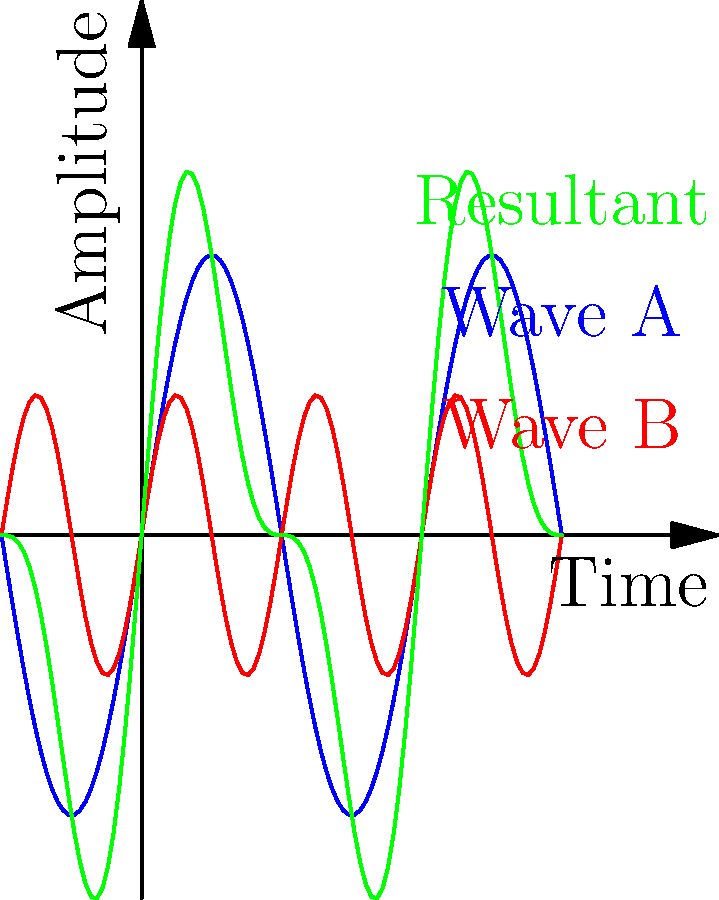In the studio, you're mixing two sound waves to create a unique effect. Wave A (blue) has a frequency of 440 Hz, and Wave B (red) has a frequency of 880 Hz. What principle of wave topology explains the resulting green wave, and how might this affect your track's sound? To understand this scenario, let's break it down step-by-step:

1. Wave Characteristics:
   - Wave A (blue): frequency = 440 Hz (lower frequency)
   - Wave B (red): frequency = 880 Hz (higher frequency, exactly double of Wave A)

2. Superposition Principle:
   The green wave results from the superposition of Waves A and B. This principle states that when two or more waves overlap, the resulting displacement at any point is the sum of the displacements of the individual waves.

3. Interference:
   The interaction between these waves creates an interference pattern. There are two types:
   - Constructive interference: When peaks align with peaks or troughs with troughs, amplitudes add.
   - Destructive interference: When peaks align with troughs, amplitudes subtract.

4. Resultant Wave:
   The green wave shows a pattern that repeats at the frequency of Wave A (440 Hz) but with a modulation caused by Wave B.

5. Beat Phenomenon:
   Because Wave B's frequency is exactly double Wave A's, this creates a special case of interference called harmonics. The resultant wave maintains the fundamental frequency of Wave A but with an altered timbre.

6. Effect on Sound:
   - Timbre Change: The track will have a richer, more complex sound due to the harmonic relationship.
   - Amplitude Variation: The sound will have a varying loudness, creating a pulsating effect.

7. Application in Music:
   This principle is often used in sound synthesis and can create interesting rhythmic and tonal effects in hip-hop production, allowing for unique sound textures and beats.
Answer: Superposition and harmonic interference 